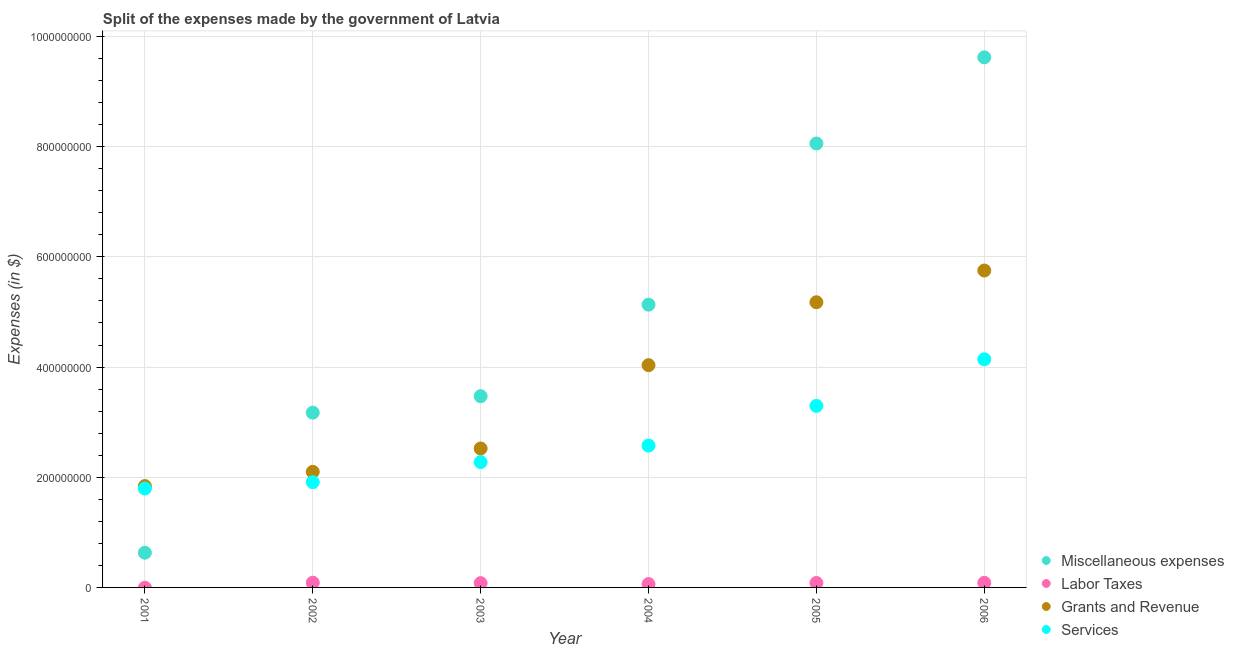Is the number of dotlines equal to the number of legend labels?
Offer a very short reply. No. What is the amount spent on grants and revenue in 2004?
Your answer should be very brief. 4.03e+08. Across all years, what is the maximum amount spent on labor taxes?
Ensure brevity in your answer.  8.60e+06. Across all years, what is the minimum amount spent on services?
Make the answer very short. 1.80e+08. What is the total amount spent on miscellaneous expenses in the graph?
Provide a succinct answer. 3.01e+09. What is the difference between the amount spent on grants and revenue in 2004 and that in 2006?
Provide a short and direct response. -1.72e+08. What is the difference between the amount spent on miscellaneous expenses in 2006 and the amount spent on services in 2004?
Provide a short and direct response. 7.05e+08. What is the average amount spent on grants and revenue per year?
Give a very brief answer. 3.57e+08. In the year 2006, what is the difference between the amount spent on services and amount spent on miscellaneous expenses?
Offer a very short reply. -5.48e+08. What is the ratio of the amount spent on grants and revenue in 2002 to that in 2006?
Give a very brief answer. 0.36. Is the difference between the amount spent on grants and revenue in 2002 and 2005 greater than the difference between the amount spent on services in 2002 and 2005?
Your answer should be very brief. No. What is the difference between the highest and the second highest amount spent on miscellaneous expenses?
Ensure brevity in your answer.  1.56e+08. What is the difference between the highest and the lowest amount spent on labor taxes?
Your answer should be compact. 8.60e+06. In how many years, is the amount spent on grants and revenue greater than the average amount spent on grants and revenue taken over all years?
Offer a terse response. 3. Is the amount spent on miscellaneous expenses strictly greater than the amount spent on services over the years?
Provide a succinct answer. No. What is the difference between two consecutive major ticks on the Y-axis?
Your answer should be very brief. 2.00e+08. Does the graph contain any zero values?
Provide a short and direct response. Yes. How are the legend labels stacked?
Ensure brevity in your answer.  Vertical. What is the title of the graph?
Keep it short and to the point. Split of the expenses made by the government of Latvia. Does "Other greenhouse gases" appear as one of the legend labels in the graph?
Your answer should be very brief. No. What is the label or title of the X-axis?
Your response must be concise. Year. What is the label or title of the Y-axis?
Offer a terse response. Expenses (in $). What is the Expenses (in $) in Miscellaneous expenses in 2001?
Your answer should be compact. 6.30e+07. What is the Expenses (in $) of Labor Taxes in 2001?
Your response must be concise. 0. What is the Expenses (in $) of Grants and Revenue in 2001?
Your response must be concise. 1.84e+08. What is the Expenses (in $) in Services in 2001?
Give a very brief answer. 1.80e+08. What is the Expenses (in $) of Miscellaneous expenses in 2002?
Make the answer very short. 3.17e+08. What is the Expenses (in $) of Labor Taxes in 2002?
Make the answer very short. 8.60e+06. What is the Expenses (in $) of Grants and Revenue in 2002?
Your answer should be compact. 2.10e+08. What is the Expenses (in $) in Services in 2002?
Give a very brief answer. 1.91e+08. What is the Expenses (in $) of Miscellaneous expenses in 2003?
Provide a short and direct response. 3.47e+08. What is the Expenses (in $) in Labor Taxes in 2003?
Offer a terse response. 7.80e+06. What is the Expenses (in $) in Grants and Revenue in 2003?
Your answer should be very brief. 2.52e+08. What is the Expenses (in $) of Services in 2003?
Provide a short and direct response. 2.28e+08. What is the Expenses (in $) of Miscellaneous expenses in 2004?
Provide a succinct answer. 5.13e+08. What is the Expenses (in $) of Labor Taxes in 2004?
Offer a terse response. 6.10e+06. What is the Expenses (in $) of Grants and Revenue in 2004?
Offer a very short reply. 4.03e+08. What is the Expenses (in $) of Services in 2004?
Provide a succinct answer. 2.58e+08. What is the Expenses (in $) in Miscellaneous expenses in 2005?
Provide a short and direct response. 8.06e+08. What is the Expenses (in $) of Labor Taxes in 2005?
Your response must be concise. 8.10e+06. What is the Expenses (in $) of Grants and Revenue in 2005?
Provide a succinct answer. 5.18e+08. What is the Expenses (in $) in Services in 2005?
Provide a succinct answer. 3.30e+08. What is the Expenses (in $) of Miscellaneous expenses in 2006?
Offer a terse response. 9.62e+08. What is the Expenses (in $) in Labor Taxes in 2006?
Provide a succinct answer. 8.40e+06. What is the Expenses (in $) in Grants and Revenue in 2006?
Offer a very short reply. 5.75e+08. What is the Expenses (in $) of Services in 2006?
Offer a very short reply. 4.14e+08. Across all years, what is the maximum Expenses (in $) in Miscellaneous expenses?
Your response must be concise. 9.62e+08. Across all years, what is the maximum Expenses (in $) in Labor Taxes?
Offer a terse response. 8.60e+06. Across all years, what is the maximum Expenses (in $) in Grants and Revenue?
Provide a short and direct response. 5.75e+08. Across all years, what is the maximum Expenses (in $) of Services?
Offer a terse response. 4.14e+08. Across all years, what is the minimum Expenses (in $) of Miscellaneous expenses?
Your response must be concise. 6.30e+07. Across all years, what is the minimum Expenses (in $) in Grants and Revenue?
Your answer should be compact. 1.84e+08. Across all years, what is the minimum Expenses (in $) in Services?
Provide a short and direct response. 1.80e+08. What is the total Expenses (in $) in Miscellaneous expenses in the graph?
Your answer should be very brief. 3.01e+09. What is the total Expenses (in $) of Labor Taxes in the graph?
Your response must be concise. 3.90e+07. What is the total Expenses (in $) in Grants and Revenue in the graph?
Provide a short and direct response. 2.14e+09. What is the total Expenses (in $) in Services in the graph?
Offer a very short reply. 1.60e+09. What is the difference between the Expenses (in $) in Miscellaneous expenses in 2001 and that in 2002?
Make the answer very short. -2.54e+08. What is the difference between the Expenses (in $) in Grants and Revenue in 2001 and that in 2002?
Offer a very short reply. -2.59e+07. What is the difference between the Expenses (in $) in Services in 2001 and that in 2002?
Your response must be concise. -1.15e+07. What is the difference between the Expenses (in $) of Miscellaneous expenses in 2001 and that in 2003?
Give a very brief answer. -2.84e+08. What is the difference between the Expenses (in $) of Grants and Revenue in 2001 and that in 2003?
Your answer should be very brief. -6.82e+07. What is the difference between the Expenses (in $) of Services in 2001 and that in 2003?
Give a very brief answer. -4.80e+07. What is the difference between the Expenses (in $) of Miscellaneous expenses in 2001 and that in 2004?
Provide a succinct answer. -4.50e+08. What is the difference between the Expenses (in $) in Grants and Revenue in 2001 and that in 2004?
Offer a terse response. -2.19e+08. What is the difference between the Expenses (in $) in Services in 2001 and that in 2004?
Your answer should be compact. -7.80e+07. What is the difference between the Expenses (in $) of Miscellaneous expenses in 2001 and that in 2005?
Offer a terse response. -7.43e+08. What is the difference between the Expenses (in $) of Grants and Revenue in 2001 and that in 2005?
Give a very brief answer. -3.34e+08. What is the difference between the Expenses (in $) in Services in 2001 and that in 2005?
Your response must be concise. -1.50e+08. What is the difference between the Expenses (in $) of Miscellaneous expenses in 2001 and that in 2006?
Ensure brevity in your answer.  -8.99e+08. What is the difference between the Expenses (in $) of Grants and Revenue in 2001 and that in 2006?
Offer a very short reply. -3.91e+08. What is the difference between the Expenses (in $) in Services in 2001 and that in 2006?
Offer a very short reply. -2.34e+08. What is the difference between the Expenses (in $) in Miscellaneous expenses in 2002 and that in 2003?
Make the answer very short. -2.99e+07. What is the difference between the Expenses (in $) in Labor Taxes in 2002 and that in 2003?
Give a very brief answer. 8.00e+05. What is the difference between the Expenses (in $) in Grants and Revenue in 2002 and that in 2003?
Give a very brief answer. -4.24e+07. What is the difference between the Expenses (in $) of Services in 2002 and that in 2003?
Your response must be concise. -3.64e+07. What is the difference between the Expenses (in $) of Miscellaneous expenses in 2002 and that in 2004?
Offer a very short reply. -1.96e+08. What is the difference between the Expenses (in $) in Labor Taxes in 2002 and that in 2004?
Offer a very short reply. 2.50e+06. What is the difference between the Expenses (in $) in Grants and Revenue in 2002 and that in 2004?
Offer a terse response. -1.94e+08. What is the difference between the Expenses (in $) of Services in 2002 and that in 2004?
Offer a terse response. -6.64e+07. What is the difference between the Expenses (in $) in Miscellaneous expenses in 2002 and that in 2005?
Provide a short and direct response. -4.89e+08. What is the difference between the Expenses (in $) of Labor Taxes in 2002 and that in 2005?
Your response must be concise. 5.00e+05. What is the difference between the Expenses (in $) in Grants and Revenue in 2002 and that in 2005?
Offer a terse response. -3.08e+08. What is the difference between the Expenses (in $) in Services in 2002 and that in 2005?
Give a very brief answer. -1.38e+08. What is the difference between the Expenses (in $) of Miscellaneous expenses in 2002 and that in 2006?
Keep it short and to the point. -6.45e+08. What is the difference between the Expenses (in $) of Grants and Revenue in 2002 and that in 2006?
Offer a terse response. -3.65e+08. What is the difference between the Expenses (in $) in Services in 2002 and that in 2006?
Give a very brief answer. -2.23e+08. What is the difference between the Expenses (in $) of Miscellaneous expenses in 2003 and that in 2004?
Your answer should be compact. -1.66e+08. What is the difference between the Expenses (in $) of Labor Taxes in 2003 and that in 2004?
Your answer should be compact. 1.70e+06. What is the difference between the Expenses (in $) in Grants and Revenue in 2003 and that in 2004?
Offer a terse response. -1.51e+08. What is the difference between the Expenses (in $) of Services in 2003 and that in 2004?
Your answer should be compact. -3.00e+07. What is the difference between the Expenses (in $) of Miscellaneous expenses in 2003 and that in 2005?
Offer a terse response. -4.59e+08. What is the difference between the Expenses (in $) of Labor Taxes in 2003 and that in 2005?
Provide a short and direct response. -3.00e+05. What is the difference between the Expenses (in $) in Grants and Revenue in 2003 and that in 2005?
Offer a terse response. -2.65e+08. What is the difference between the Expenses (in $) of Services in 2003 and that in 2005?
Your answer should be very brief. -1.02e+08. What is the difference between the Expenses (in $) of Miscellaneous expenses in 2003 and that in 2006?
Your answer should be compact. -6.15e+08. What is the difference between the Expenses (in $) of Labor Taxes in 2003 and that in 2006?
Give a very brief answer. -6.00e+05. What is the difference between the Expenses (in $) of Grants and Revenue in 2003 and that in 2006?
Your response must be concise. -3.23e+08. What is the difference between the Expenses (in $) of Services in 2003 and that in 2006?
Offer a very short reply. -1.86e+08. What is the difference between the Expenses (in $) in Miscellaneous expenses in 2004 and that in 2005?
Your answer should be compact. -2.92e+08. What is the difference between the Expenses (in $) of Labor Taxes in 2004 and that in 2005?
Give a very brief answer. -2.00e+06. What is the difference between the Expenses (in $) in Grants and Revenue in 2004 and that in 2005?
Offer a very short reply. -1.14e+08. What is the difference between the Expenses (in $) in Services in 2004 and that in 2005?
Offer a terse response. -7.20e+07. What is the difference between the Expenses (in $) of Miscellaneous expenses in 2004 and that in 2006?
Ensure brevity in your answer.  -4.49e+08. What is the difference between the Expenses (in $) in Labor Taxes in 2004 and that in 2006?
Make the answer very short. -2.30e+06. What is the difference between the Expenses (in $) of Grants and Revenue in 2004 and that in 2006?
Provide a short and direct response. -1.72e+08. What is the difference between the Expenses (in $) in Services in 2004 and that in 2006?
Offer a very short reply. -1.56e+08. What is the difference between the Expenses (in $) in Miscellaneous expenses in 2005 and that in 2006?
Ensure brevity in your answer.  -1.56e+08. What is the difference between the Expenses (in $) of Grants and Revenue in 2005 and that in 2006?
Offer a terse response. -5.76e+07. What is the difference between the Expenses (in $) in Services in 2005 and that in 2006?
Your response must be concise. -8.45e+07. What is the difference between the Expenses (in $) of Miscellaneous expenses in 2001 and the Expenses (in $) of Labor Taxes in 2002?
Keep it short and to the point. 5.44e+07. What is the difference between the Expenses (in $) of Miscellaneous expenses in 2001 and the Expenses (in $) of Grants and Revenue in 2002?
Give a very brief answer. -1.47e+08. What is the difference between the Expenses (in $) of Miscellaneous expenses in 2001 and the Expenses (in $) of Services in 2002?
Ensure brevity in your answer.  -1.28e+08. What is the difference between the Expenses (in $) of Grants and Revenue in 2001 and the Expenses (in $) of Services in 2002?
Offer a terse response. -7.10e+06. What is the difference between the Expenses (in $) of Miscellaneous expenses in 2001 and the Expenses (in $) of Labor Taxes in 2003?
Provide a short and direct response. 5.52e+07. What is the difference between the Expenses (in $) of Miscellaneous expenses in 2001 and the Expenses (in $) of Grants and Revenue in 2003?
Your response must be concise. -1.89e+08. What is the difference between the Expenses (in $) of Miscellaneous expenses in 2001 and the Expenses (in $) of Services in 2003?
Provide a short and direct response. -1.64e+08. What is the difference between the Expenses (in $) in Grants and Revenue in 2001 and the Expenses (in $) in Services in 2003?
Offer a terse response. -4.36e+07. What is the difference between the Expenses (in $) of Miscellaneous expenses in 2001 and the Expenses (in $) of Labor Taxes in 2004?
Provide a short and direct response. 5.69e+07. What is the difference between the Expenses (in $) in Miscellaneous expenses in 2001 and the Expenses (in $) in Grants and Revenue in 2004?
Your response must be concise. -3.40e+08. What is the difference between the Expenses (in $) in Miscellaneous expenses in 2001 and the Expenses (in $) in Services in 2004?
Give a very brief answer. -1.94e+08. What is the difference between the Expenses (in $) of Grants and Revenue in 2001 and the Expenses (in $) of Services in 2004?
Provide a short and direct response. -7.36e+07. What is the difference between the Expenses (in $) in Miscellaneous expenses in 2001 and the Expenses (in $) in Labor Taxes in 2005?
Make the answer very short. 5.49e+07. What is the difference between the Expenses (in $) in Miscellaneous expenses in 2001 and the Expenses (in $) in Grants and Revenue in 2005?
Offer a very short reply. -4.55e+08. What is the difference between the Expenses (in $) of Miscellaneous expenses in 2001 and the Expenses (in $) of Services in 2005?
Your answer should be very brief. -2.66e+08. What is the difference between the Expenses (in $) of Grants and Revenue in 2001 and the Expenses (in $) of Services in 2005?
Provide a short and direct response. -1.46e+08. What is the difference between the Expenses (in $) in Miscellaneous expenses in 2001 and the Expenses (in $) in Labor Taxes in 2006?
Keep it short and to the point. 5.46e+07. What is the difference between the Expenses (in $) in Miscellaneous expenses in 2001 and the Expenses (in $) in Grants and Revenue in 2006?
Give a very brief answer. -5.12e+08. What is the difference between the Expenses (in $) in Miscellaneous expenses in 2001 and the Expenses (in $) in Services in 2006?
Offer a very short reply. -3.51e+08. What is the difference between the Expenses (in $) in Grants and Revenue in 2001 and the Expenses (in $) in Services in 2006?
Give a very brief answer. -2.30e+08. What is the difference between the Expenses (in $) in Miscellaneous expenses in 2002 and the Expenses (in $) in Labor Taxes in 2003?
Your response must be concise. 3.09e+08. What is the difference between the Expenses (in $) in Miscellaneous expenses in 2002 and the Expenses (in $) in Grants and Revenue in 2003?
Offer a very short reply. 6.50e+07. What is the difference between the Expenses (in $) in Miscellaneous expenses in 2002 and the Expenses (in $) in Services in 2003?
Offer a very short reply. 8.97e+07. What is the difference between the Expenses (in $) in Labor Taxes in 2002 and the Expenses (in $) in Grants and Revenue in 2003?
Keep it short and to the point. -2.44e+08. What is the difference between the Expenses (in $) in Labor Taxes in 2002 and the Expenses (in $) in Services in 2003?
Make the answer very short. -2.19e+08. What is the difference between the Expenses (in $) of Grants and Revenue in 2002 and the Expenses (in $) of Services in 2003?
Provide a succinct answer. -1.76e+07. What is the difference between the Expenses (in $) of Miscellaneous expenses in 2002 and the Expenses (in $) of Labor Taxes in 2004?
Provide a short and direct response. 3.11e+08. What is the difference between the Expenses (in $) in Miscellaneous expenses in 2002 and the Expenses (in $) in Grants and Revenue in 2004?
Ensure brevity in your answer.  -8.62e+07. What is the difference between the Expenses (in $) of Miscellaneous expenses in 2002 and the Expenses (in $) of Services in 2004?
Your answer should be compact. 5.97e+07. What is the difference between the Expenses (in $) in Labor Taxes in 2002 and the Expenses (in $) in Grants and Revenue in 2004?
Give a very brief answer. -3.95e+08. What is the difference between the Expenses (in $) in Labor Taxes in 2002 and the Expenses (in $) in Services in 2004?
Provide a short and direct response. -2.49e+08. What is the difference between the Expenses (in $) of Grants and Revenue in 2002 and the Expenses (in $) of Services in 2004?
Provide a short and direct response. -4.76e+07. What is the difference between the Expenses (in $) of Miscellaneous expenses in 2002 and the Expenses (in $) of Labor Taxes in 2005?
Your answer should be very brief. 3.09e+08. What is the difference between the Expenses (in $) in Miscellaneous expenses in 2002 and the Expenses (in $) in Grants and Revenue in 2005?
Offer a very short reply. -2.00e+08. What is the difference between the Expenses (in $) of Miscellaneous expenses in 2002 and the Expenses (in $) of Services in 2005?
Your answer should be very brief. -1.23e+07. What is the difference between the Expenses (in $) in Labor Taxes in 2002 and the Expenses (in $) in Grants and Revenue in 2005?
Your response must be concise. -5.09e+08. What is the difference between the Expenses (in $) in Labor Taxes in 2002 and the Expenses (in $) in Services in 2005?
Provide a short and direct response. -3.21e+08. What is the difference between the Expenses (in $) in Grants and Revenue in 2002 and the Expenses (in $) in Services in 2005?
Your answer should be very brief. -1.20e+08. What is the difference between the Expenses (in $) in Miscellaneous expenses in 2002 and the Expenses (in $) in Labor Taxes in 2006?
Provide a succinct answer. 3.09e+08. What is the difference between the Expenses (in $) of Miscellaneous expenses in 2002 and the Expenses (in $) of Grants and Revenue in 2006?
Offer a terse response. -2.58e+08. What is the difference between the Expenses (in $) of Miscellaneous expenses in 2002 and the Expenses (in $) of Services in 2006?
Provide a succinct answer. -9.68e+07. What is the difference between the Expenses (in $) of Labor Taxes in 2002 and the Expenses (in $) of Grants and Revenue in 2006?
Ensure brevity in your answer.  -5.67e+08. What is the difference between the Expenses (in $) of Labor Taxes in 2002 and the Expenses (in $) of Services in 2006?
Your answer should be compact. -4.05e+08. What is the difference between the Expenses (in $) of Grants and Revenue in 2002 and the Expenses (in $) of Services in 2006?
Offer a very short reply. -2.04e+08. What is the difference between the Expenses (in $) of Miscellaneous expenses in 2003 and the Expenses (in $) of Labor Taxes in 2004?
Keep it short and to the point. 3.41e+08. What is the difference between the Expenses (in $) in Miscellaneous expenses in 2003 and the Expenses (in $) in Grants and Revenue in 2004?
Ensure brevity in your answer.  -5.63e+07. What is the difference between the Expenses (in $) of Miscellaneous expenses in 2003 and the Expenses (in $) of Services in 2004?
Your response must be concise. 8.96e+07. What is the difference between the Expenses (in $) of Labor Taxes in 2003 and the Expenses (in $) of Grants and Revenue in 2004?
Offer a terse response. -3.96e+08. What is the difference between the Expenses (in $) of Labor Taxes in 2003 and the Expenses (in $) of Services in 2004?
Provide a succinct answer. -2.50e+08. What is the difference between the Expenses (in $) of Grants and Revenue in 2003 and the Expenses (in $) of Services in 2004?
Make the answer very short. -5.30e+06. What is the difference between the Expenses (in $) in Miscellaneous expenses in 2003 and the Expenses (in $) in Labor Taxes in 2005?
Make the answer very short. 3.39e+08. What is the difference between the Expenses (in $) in Miscellaneous expenses in 2003 and the Expenses (in $) in Grants and Revenue in 2005?
Provide a succinct answer. -1.70e+08. What is the difference between the Expenses (in $) of Miscellaneous expenses in 2003 and the Expenses (in $) of Services in 2005?
Offer a very short reply. 1.76e+07. What is the difference between the Expenses (in $) in Labor Taxes in 2003 and the Expenses (in $) in Grants and Revenue in 2005?
Give a very brief answer. -5.10e+08. What is the difference between the Expenses (in $) of Labor Taxes in 2003 and the Expenses (in $) of Services in 2005?
Your answer should be compact. -3.22e+08. What is the difference between the Expenses (in $) of Grants and Revenue in 2003 and the Expenses (in $) of Services in 2005?
Make the answer very short. -7.73e+07. What is the difference between the Expenses (in $) in Miscellaneous expenses in 2003 and the Expenses (in $) in Labor Taxes in 2006?
Your answer should be very brief. 3.39e+08. What is the difference between the Expenses (in $) in Miscellaneous expenses in 2003 and the Expenses (in $) in Grants and Revenue in 2006?
Give a very brief answer. -2.28e+08. What is the difference between the Expenses (in $) of Miscellaneous expenses in 2003 and the Expenses (in $) of Services in 2006?
Your answer should be compact. -6.69e+07. What is the difference between the Expenses (in $) of Labor Taxes in 2003 and the Expenses (in $) of Grants and Revenue in 2006?
Provide a short and direct response. -5.67e+08. What is the difference between the Expenses (in $) of Labor Taxes in 2003 and the Expenses (in $) of Services in 2006?
Your response must be concise. -4.06e+08. What is the difference between the Expenses (in $) of Grants and Revenue in 2003 and the Expenses (in $) of Services in 2006?
Offer a terse response. -1.62e+08. What is the difference between the Expenses (in $) in Miscellaneous expenses in 2004 and the Expenses (in $) in Labor Taxes in 2005?
Make the answer very short. 5.05e+08. What is the difference between the Expenses (in $) of Miscellaneous expenses in 2004 and the Expenses (in $) of Grants and Revenue in 2005?
Offer a terse response. -4.40e+06. What is the difference between the Expenses (in $) of Miscellaneous expenses in 2004 and the Expenses (in $) of Services in 2005?
Give a very brief answer. 1.84e+08. What is the difference between the Expenses (in $) in Labor Taxes in 2004 and the Expenses (in $) in Grants and Revenue in 2005?
Give a very brief answer. -5.12e+08. What is the difference between the Expenses (in $) in Labor Taxes in 2004 and the Expenses (in $) in Services in 2005?
Offer a terse response. -3.23e+08. What is the difference between the Expenses (in $) in Grants and Revenue in 2004 and the Expenses (in $) in Services in 2005?
Your answer should be compact. 7.39e+07. What is the difference between the Expenses (in $) of Miscellaneous expenses in 2004 and the Expenses (in $) of Labor Taxes in 2006?
Keep it short and to the point. 5.05e+08. What is the difference between the Expenses (in $) in Miscellaneous expenses in 2004 and the Expenses (in $) in Grants and Revenue in 2006?
Keep it short and to the point. -6.20e+07. What is the difference between the Expenses (in $) in Miscellaneous expenses in 2004 and the Expenses (in $) in Services in 2006?
Provide a short and direct response. 9.92e+07. What is the difference between the Expenses (in $) of Labor Taxes in 2004 and the Expenses (in $) of Grants and Revenue in 2006?
Provide a short and direct response. -5.69e+08. What is the difference between the Expenses (in $) of Labor Taxes in 2004 and the Expenses (in $) of Services in 2006?
Provide a short and direct response. -4.08e+08. What is the difference between the Expenses (in $) in Grants and Revenue in 2004 and the Expenses (in $) in Services in 2006?
Provide a succinct answer. -1.06e+07. What is the difference between the Expenses (in $) in Miscellaneous expenses in 2005 and the Expenses (in $) in Labor Taxes in 2006?
Your response must be concise. 7.97e+08. What is the difference between the Expenses (in $) of Miscellaneous expenses in 2005 and the Expenses (in $) of Grants and Revenue in 2006?
Ensure brevity in your answer.  2.30e+08. What is the difference between the Expenses (in $) in Miscellaneous expenses in 2005 and the Expenses (in $) in Services in 2006?
Offer a very short reply. 3.92e+08. What is the difference between the Expenses (in $) in Labor Taxes in 2005 and the Expenses (in $) in Grants and Revenue in 2006?
Ensure brevity in your answer.  -5.67e+08. What is the difference between the Expenses (in $) in Labor Taxes in 2005 and the Expenses (in $) in Services in 2006?
Provide a succinct answer. -4.06e+08. What is the difference between the Expenses (in $) of Grants and Revenue in 2005 and the Expenses (in $) of Services in 2006?
Give a very brief answer. 1.04e+08. What is the average Expenses (in $) of Miscellaneous expenses per year?
Provide a succinct answer. 5.01e+08. What is the average Expenses (in $) in Labor Taxes per year?
Provide a succinct answer. 6.50e+06. What is the average Expenses (in $) of Grants and Revenue per year?
Provide a succinct answer. 3.57e+08. What is the average Expenses (in $) in Services per year?
Offer a terse response. 2.67e+08. In the year 2001, what is the difference between the Expenses (in $) of Miscellaneous expenses and Expenses (in $) of Grants and Revenue?
Offer a terse response. -1.21e+08. In the year 2001, what is the difference between the Expenses (in $) of Miscellaneous expenses and Expenses (in $) of Services?
Provide a short and direct response. -1.17e+08. In the year 2001, what is the difference between the Expenses (in $) of Grants and Revenue and Expenses (in $) of Services?
Give a very brief answer. 4.41e+06. In the year 2002, what is the difference between the Expenses (in $) of Miscellaneous expenses and Expenses (in $) of Labor Taxes?
Your answer should be compact. 3.09e+08. In the year 2002, what is the difference between the Expenses (in $) in Miscellaneous expenses and Expenses (in $) in Grants and Revenue?
Offer a very short reply. 1.07e+08. In the year 2002, what is the difference between the Expenses (in $) in Miscellaneous expenses and Expenses (in $) in Services?
Give a very brief answer. 1.26e+08. In the year 2002, what is the difference between the Expenses (in $) of Labor Taxes and Expenses (in $) of Grants and Revenue?
Offer a terse response. -2.01e+08. In the year 2002, what is the difference between the Expenses (in $) in Labor Taxes and Expenses (in $) in Services?
Your response must be concise. -1.82e+08. In the year 2002, what is the difference between the Expenses (in $) in Grants and Revenue and Expenses (in $) in Services?
Your answer should be very brief. 1.88e+07. In the year 2003, what is the difference between the Expenses (in $) in Miscellaneous expenses and Expenses (in $) in Labor Taxes?
Make the answer very short. 3.39e+08. In the year 2003, what is the difference between the Expenses (in $) of Miscellaneous expenses and Expenses (in $) of Grants and Revenue?
Your answer should be compact. 9.49e+07. In the year 2003, what is the difference between the Expenses (in $) in Miscellaneous expenses and Expenses (in $) in Services?
Your answer should be very brief. 1.20e+08. In the year 2003, what is the difference between the Expenses (in $) in Labor Taxes and Expenses (in $) in Grants and Revenue?
Offer a terse response. -2.44e+08. In the year 2003, what is the difference between the Expenses (in $) of Labor Taxes and Expenses (in $) of Services?
Your answer should be compact. -2.20e+08. In the year 2003, what is the difference between the Expenses (in $) in Grants and Revenue and Expenses (in $) in Services?
Give a very brief answer. 2.47e+07. In the year 2004, what is the difference between the Expenses (in $) in Miscellaneous expenses and Expenses (in $) in Labor Taxes?
Offer a very short reply. 5.07e+08. In the year 2004, what is the difference between the Expenses (in $) of Miscellaneous expenses and Expenses (in $) of Grants and Revenue?
Your answer should be compact. 1.10e+08. In the year 2004, what is the difference between the Expenses (in $) of Miscellaneous expenses and Expenses (in $) of Services?
Your answer should be compact. 2.56e+08. In the year 2004, what is the difference between the Expenses (in $) of Labor Taxes and Expenses (in $) of Grants and Revenue?
Provide a short and direct response. -3.97e+08. In the year 2004, what is the difference between the Expenses (in $) of Labor Taxes and Expenses (in $) of Services?
Offer a terse response. -2.51e+08. In the year 2004, what is the difference between the Expenses (in $) of Grants and Revenue and Expenses (in $) of Services?
Your answer should be very brief. 1.46e+08. In the year 2005, what is the difference between the Expenses (in $) in Miscellaneous expenses and Expenses (in $) in Labor Taxes?
Your response must be concise. 7.98e+08. In the year 2005, what is the difference between the Expenses (in $) of Miscellaneous expenses and Expenses (in $) of Grants and Revenue?
Your answer should be very brief. 2.88e+08. In the year 2005, what is the difference between the Expenses (in $) in Miscellaneous expenses and Expenses (in $) in Services?
Keep it short and to the point. 4.76e+08. In the year 2005, what is the difference between the Expenses (in $) of Labor Taxes and Expenses (in $) of Grants and Revenue?
Offer a very short reply. -5.10e+08. In the year 2005, what is the difference between the Expenses (in $) of Labor Taxes and Expenses (in $) of Services?
Ensure brevity in your answer.  -3.21e+08. In the year 2005, what is the difference between the Expenses (in $) of Grants and Revenue and Expenses (in $) of Services?
Give a very brief answer. 1.88e+08. In the year 2006, what is the difference between the Expenses (in $) in Miscellaneous expenses and Expenses (in $) in Labor Taxes?
Your answer should be compact. 9.54e+08. In the year 2006, what is the difference between the Expenses (in $) of Miscellaneous expenses and Expenses (in $) of Grants and Revenue?
Provide a succinct answer. 3.87e+08. In the year 2006, what is the difference between the Expenses (in $) of Miscellaneous expenses and Expenses (in $) of Services?
Provide a short and direct response. 5.48e+08. In the year 2006, what is the difference between the Expenses (in $) of Labor Taxes and Expenses (in $) of Grants and Revenue?
Your answer should be compact. -5.67e+08. In the year 2006, what is the difference between the Expenses (in $) of Labor Taxes and Expenses (in $) of Services?
Ensure brevity in your answer.  -4.06e+08. In the year 2006, what is the difference between the Expenses (in $) of Grants and Revenue and Expenses (in $) of Services?
Your answer should be very brief. 1.61e+08. What is the ratio of the Expenses (in $) in Miscellaneous expenses in 2001 to that in 2002?
Offer a very short reply. 0.2. What is the ratio of the Expenses (in $) in Grants and Revenue in 2001 to that in 2002?
Provide a succinct answer. 0.88. What is the ratio of the Expenses (in $) of Services in 2001 to that in 2002?
Offer a very short reply. 0.94. What is the ratio of the Expenses (in $) of Miscellaneous expenses in 2001 to that in 2003?
Give a very brief answer. 0.18. What is the ratio of the Expenses (in $) of Grants and Revenue in 2001 to that in 2003?
Your response must be concise. 0.73. What is the ratio of the Expenses (in $) in Services in 2001 to that in 2003?
Provide a succinct answer. 0.79. What is the ratio of the Expenses (in $) in Miscellaneous expenses in 2001 to that in 2004?
Give a very brief answer. 0.12. What is the ratio of the Expenses (in $) in Grants and Revenue in 2001 to that in 2004?
Your answer should be compact. 0.46. What is the ratio of the Expenses (in $) in Services in 2001 to that in 2004?
Keep it short and to the point. 0.7. What is the ratio of the Expenses (in $) of Miscellaneous expenses in 2001 to that in 2005?
Ensure brevity in your answer.  0.08. What is the ratio of the Expenses (in $) of Grants and Revenue in 2001 to that in 2005?
Provide a succinct answer. 0.36. What is the ratio of the Expenses (in $) of Services in 2001 to that in 2005?
Keep it short and to the point. 0.54. What is the ratio of the Expenses (in $) of Miscellaneous expenses in 2001 to that in 2006?
Give a very brief answer. 0.07. What is the ratio of the Expenses (in $) of Grants and Revenue in 2001 to that in 2006?
Your response must be concise. 0.32. What is the ratio of the Expenses (in $) in Services in 2001 to that in 2006?
Your response must be concise. 0.43. What is the ratio of the Expenses (in $) in Miscellaneous expenses in 2002 to that in 2003?
Keep it short and to the point. 0.91. What is the ratio of the Expenses (in $) of Labor Taxes in 2002 to that in 2003?
Your answer should be very brief. 1.1. What is the ratio of the Expenses (in $) in Grants and Revenue in 2002 to that in 2003?
Offer a very short reply. 0.83. What is the ratio of the Expenses (in $) in Services in 2002 to that in 2003?
Offer a terse response. 0.84. What is the ratio of the Expenses (in $) of Miscellaneous expenses in 2002 to that in 2004?
Offer a terse response. 0.62. What is the ratio of the Expenses (in $) in Labor Taxes in 2002 to that in 2004?
Make the answer very short. 1.41. What is the ratio of the Expenses (in $) of Grants and Revenue in 2002 to that in 2004?
Your answer should be very brief. 0.52. What is the ratio of the Expenses (in $) of Services in 2002 to that in 2004?
Keep it short and to the point. 0.74. What is the ratio of the Expenses (in $) of Miscellaneous expenses in 2002 to that in 2005?
Provide a short and direct response. 0.39. What is the ratio of the Expenses (in $) in Labor Taxes in 2002 to that in 2005?
Ensure brevity in your answer.  1.06. What is the ratio of the Expenses (in $) of Grants and Revenue in 2002 to that in 2005?
Make the answer very short. 0.41. What is the ratio of the Expenses (in $) in Services in 2002 to that in 2005?
Provide a short and direct response. 0.58. What is the ratio of the Expenses (in $) of Miscellaneous expenses in 2002 to that in 2006?
Your response must be concise. 0.33. What is the ratio of the Expenses (in $) of Labor Taxes in 2002 to that in 2006?
Provide a succinct answer. 1.02. What is the ratio of the Expenses (in $) in Grants and Revenue in 2002 to that in 2006?
Offer a very short reply. 0.36. What is the ratio of the Expenses (in $) in Services in 2002 to that in 2006?
Your response must be concise. 0.46. What is the ratio of the Expenses (in $) of Miscellaneous expenses in 2003 to that in 2004?
Offer a very short reply. 0.68. What is the ratio of the Expenses (in $) of Labor Taxes in 2003 to that in 2004?
Your answer should be compact. 1.28. What is the ratio of the Expenses (in $) of Grants and Revenue in 2003 to that in 2004?
Offer a terse response. 0.63. What is the ratio of the Expenses (in $) of Services in 2003 to that in 2004?
Offer a very short reply. 0.88. What is the ratio of the Expenses (in $) in Miscellaneous expenses in 2003 to that in 2005?
Give a very brief answer. 0.43. What is the ratio of the Expenses (in $) of Grants and Revenue in 2003 to that in 2005?
Provide a succinct answer. 0.49. What is the ratio of the Expenses (in $) in Services in 2003 to that in 2005?
Make the answer very short. 0.69. What is the ratio of the Expenses (in $) in Miscellaneous expenses in 2003 to that in 2006?
Your answer should be very brief. 0.36. What is the ratio of the Expenses (in $) of Labor Taxes in 2003 to that in 2006?
Offer a very short reply. 0.93. What is the ratio of the Expenses (in $) of Grants and Revenue in 2003 to that in 2006?
Make the answer very short. 0.44. What is the ratio of the Expenses (in $) of Services in 2003 to that in 2006?
Provide a succinct answer. 0.55. What is the ratio of the Expenses (in $) in Miscellaneous expenses in 2004 to that in 2005?
Give a very brief answer. 0.64. What is the ratio of the Expenses (in $) of Labor Taxes in 2004 to that in 2005?
Provide a succinct answer. 0.75. What is the ratio of the Expenses (in $) in Grants and Revenue in 2004 to that in 2005?
Offer a very short reply. 0.78. What is the ratio of the Expenses (in $) of Services in 2004 to that in 2005?
Give a very brief answer. 0.78. What is the ratio of the Expenses (in $) in Miscellaneous expenses in 2004 to that in 2006?
Your answer should be very brief. 0.53. What is the ratio of the Expenses (in $) in Labor Taxes in 2004 to that in 2006?
Give a very brief answer. 0.73. What is the ratio of the Expenses (in $) of Grants and Revenue in 2004 to that in 2006?
Make the answer very short. 0.7. What is the ratio of the Expenses (in $) of Services in 2004 to that in 2006?
Provide a succinct answer. 0.62. What is the ratio of the Expenses (in $) of Miscellaneous expenses in 2005 to that in 2006?
Your response must be concise. 0.84. What is the ratio of the Expenses (in $) of Grants and Revenue in 2005 to that in 2006?
Provide a succinct answer. 0.9. What is the ratio of the Expenses (in $) in Services in 2005 to that in 2006?
Your answer should be very brief. 0.8. What is the difference between the highest and the second highest Expenses (in $) in Miscellaneous expenses?
Give a very brief answer. 1.56e+08. What is the difference between the highest and the second highest Expenses (in $) of Labor Taxes?
Ensure brevity in your answer.  2.00e+05. What is the difference between the highest and the second highest Expenses (in $) of Grants and Revenue?
Provide a succinct answer. 5.76e+07. What is the difference between the highest and the second highest Expenses (in $) in Services?
Your response must be concise. 8.45e+07. What is the difference between the highest and the lowest Expenses (in $) of Miscellaneous expenses?
Offer a terse response. 8.99e+08. What is the difference between the highest and the lowest Expenses (in $) in Labor Taxes?
Give a very brief answer. 8.60e+06. What is the difference between the highest and the lowest Expenses (in $) in Grants and Revenue?
Your answer should be very brief. 3.91e+08. What is the difference between the highest and the lowest Expenses (in $) in Services?
Provide a succinct answer. 2.34e+08. 